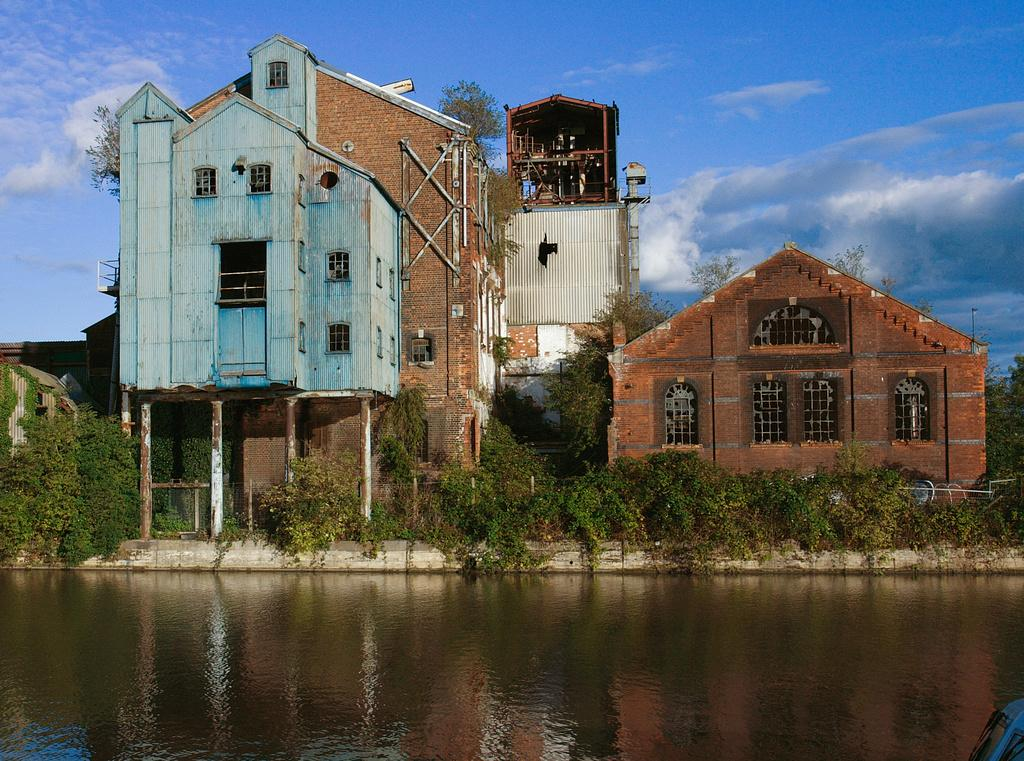What is the main feature in the foreground of the picture? There is a water body in the foreground of the picture. What can be seen in the middle of the picture? There are plants, trees, and buildings in the middle of the picture. What is visible in the background of the picture? There is sky visible in the background of the picture. What type of society is depicted in the image? The image does not depict a society; it features a water body, plants, trees, buildings, and sky. Can you tell me how many airplanes are visible at the airport in the image? There is no airport or airplanes present in the image. 